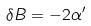<formula> <loc_0><loc_0><loc_500><loc_500>\delta B = - 2 \alpha ^ { \prime }</formula> 